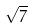<formula> <loc_0><loc_0><loc_500><loc_500>\sqrt { 7 }</formula> 